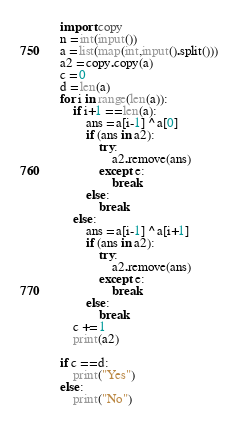<code> <loc_0><loc_0><loc_500><loc_500><_Python_>import copy
n = int(input())
a = list(map(int,input().split()))
a2 = copy.copy(a)
c = 0
d = len(a)
for i in range(len(a)):
    if i+1 == len(a):
        ans = a[i-1] ^ a[0]
        if (ans in a2):
            try:
                a2.remove(ans)
            except e:
                break
        else:
            break
    else:
        ans = a[i-1] ^ a[i+1]
        if (ans in a2):
            try:
                a2.remove(ans)
            except e:
                break
        else:
            break
    c += 1
    print(a2)

if c == d:
    print("Yes")
else:
    print("No")

</code> 